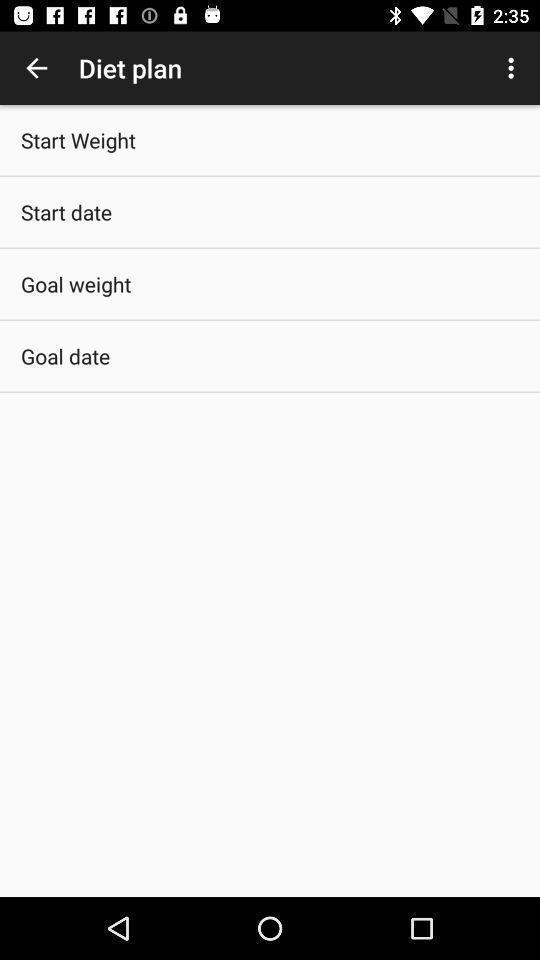Describe the content in this image. Screen displaying the diet plan options. 